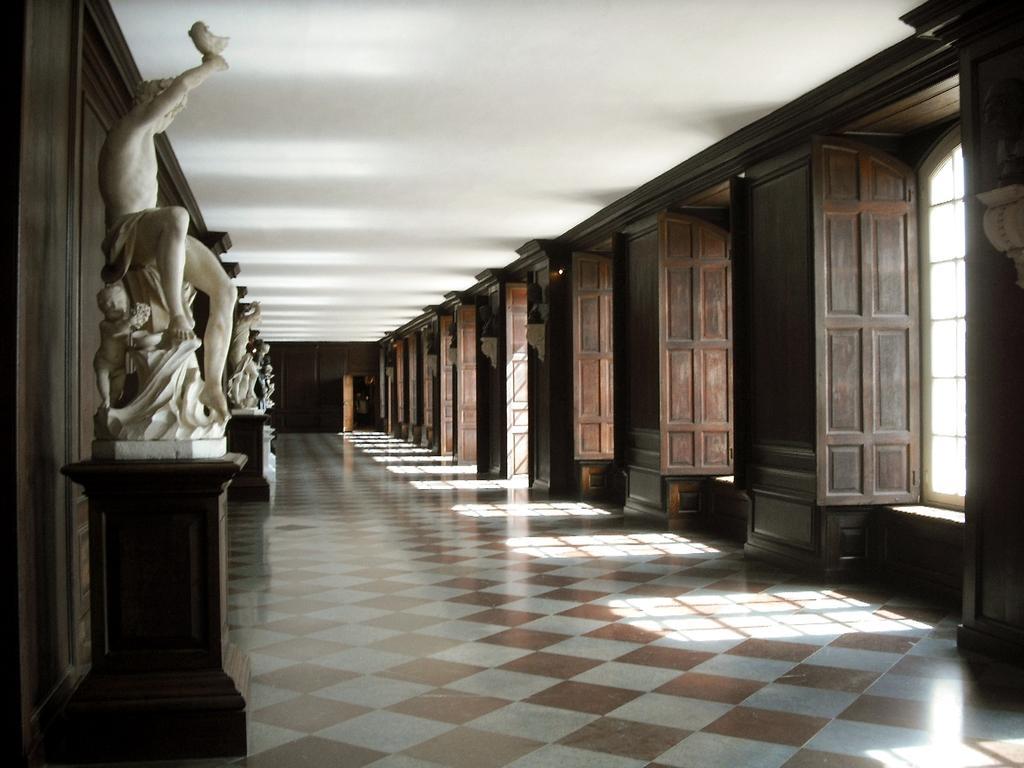Please provide a concise description of this image. In this picture there is a hall with many wooden windows. On the left side there are many white marble statues. 